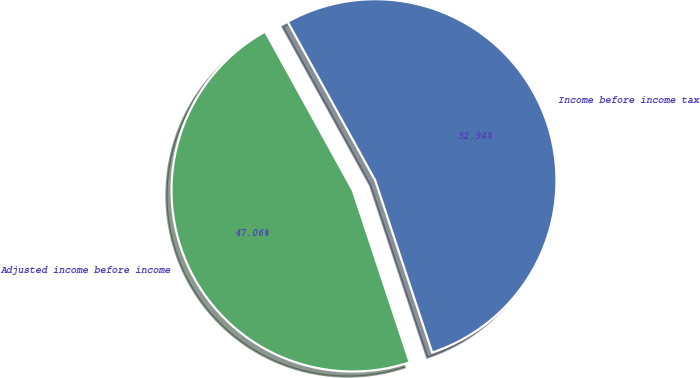<chart> <loc_0><loc_0><loc_500><loc_500><pie_chart><fcel>Income before income tax<fcel>Adjusted income before income<nl><fcel>52.94%<fcel>47.06%<nl></chart> 